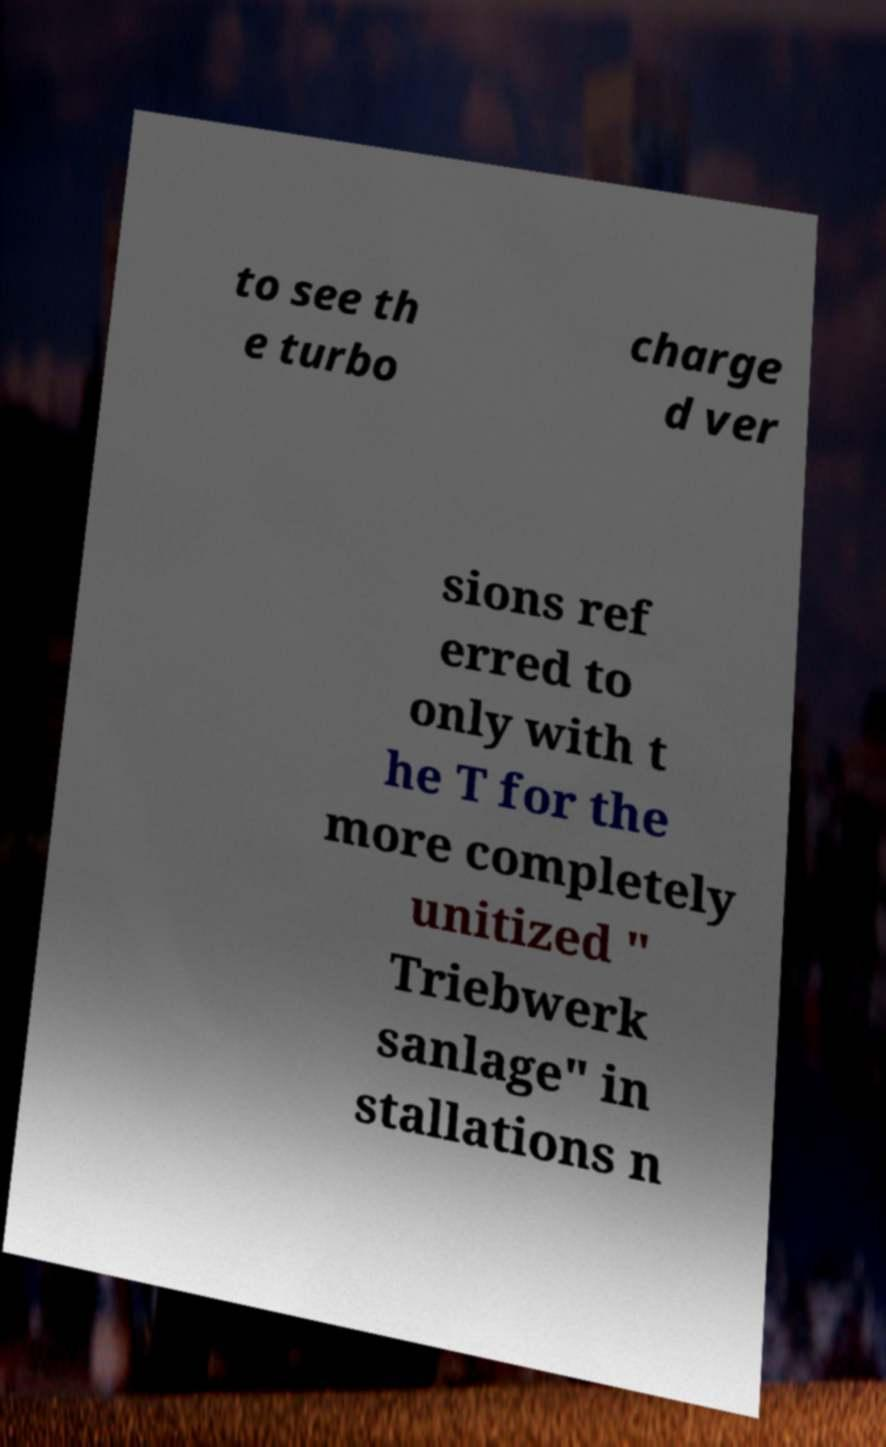Can you accurately transcribe the text from the provided image for me? to see th e turbo charge d ver sions ref erred to only with t he T for the more completely unitized " Triebwerk sanlage" in stallations n 